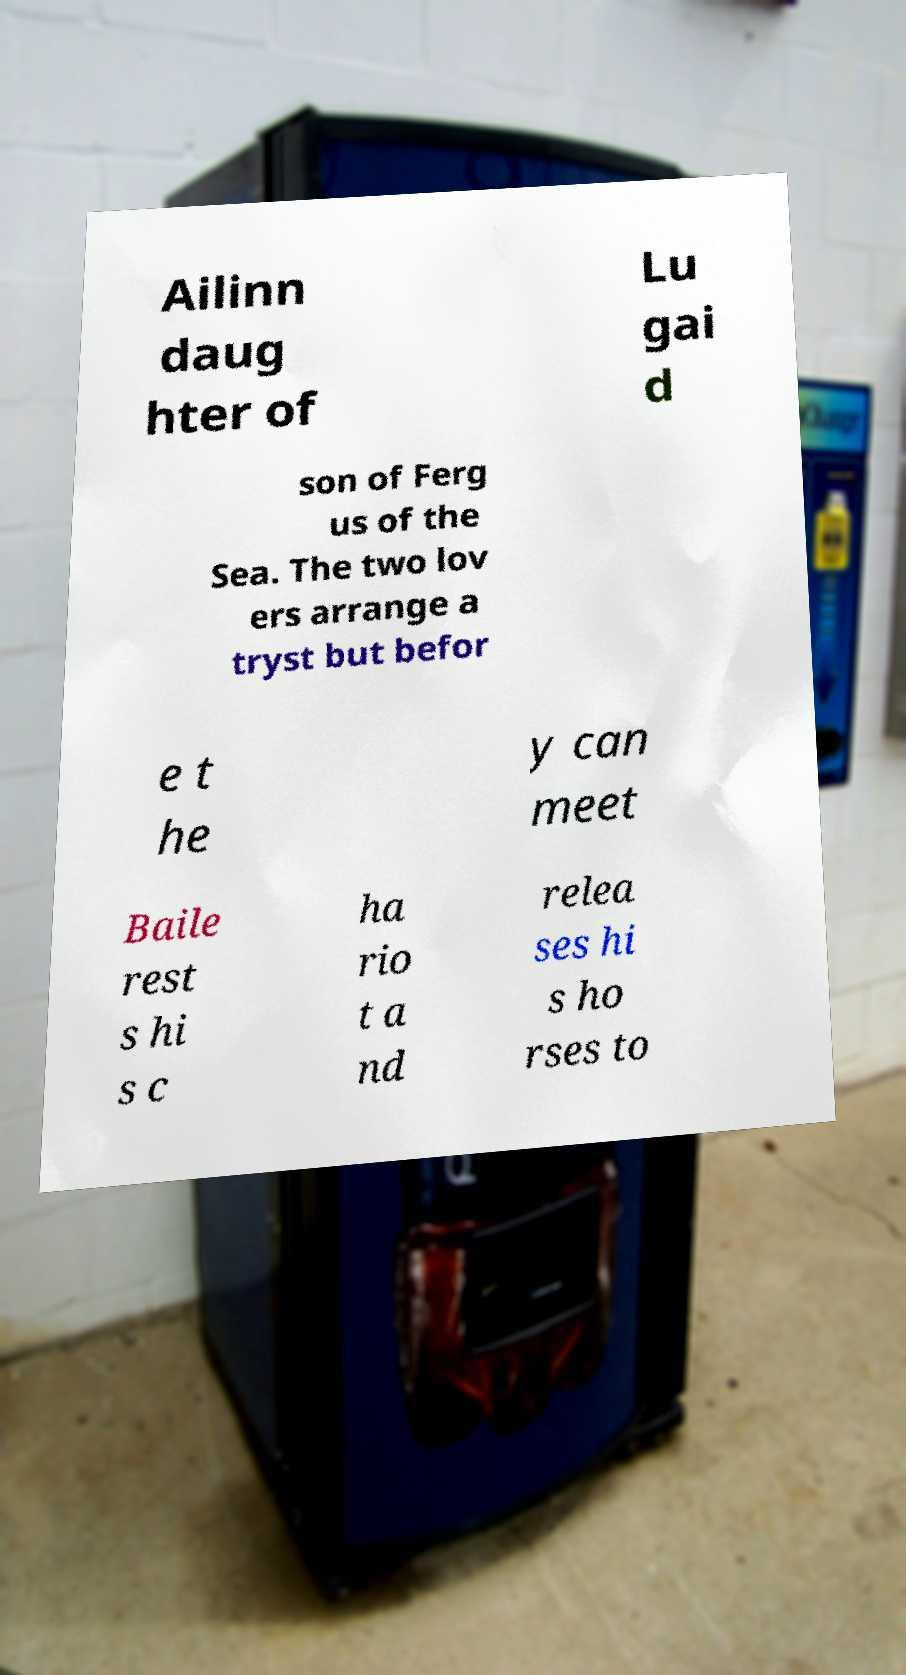I need the written content from this picture converted into text. Can you do that? Ailinn daug hter of Lu gai d son of Ferg us of the Sea. The two lov ers arrange a tryst but befor e t he y can meet Baile rest s hi s c ha rio t a nd relea ses hi s ho rses to 